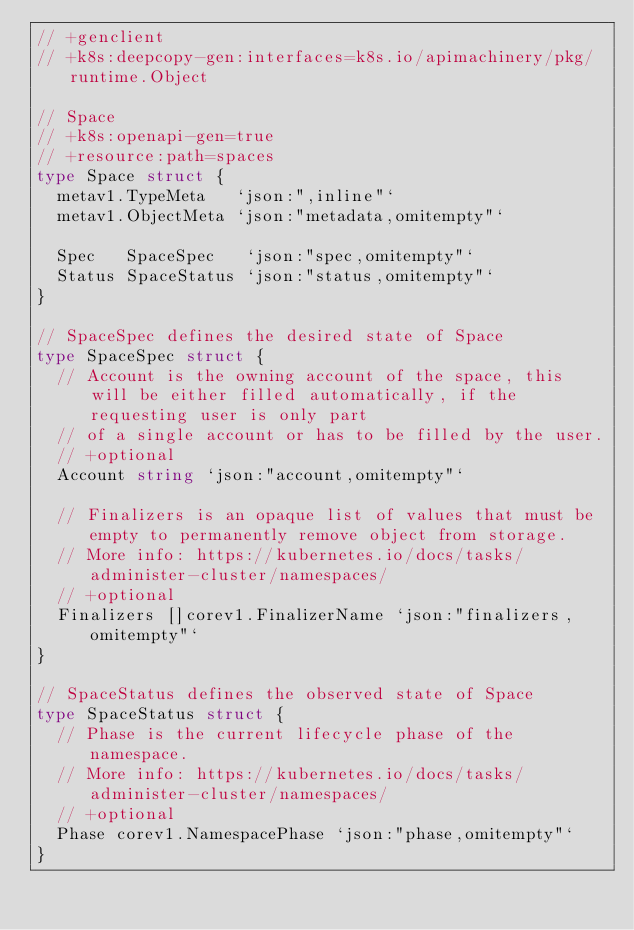<code> <loc_0><loc_0><loc_500><loc_500><_Go_>// +genclient
// +k8s:deepcopy-gen:interfaces=k8s.io/apimachinery/pkg/runtime.Object

// Space
// +k8s:openapi-gen=true
// +resource:path=spaces
type Space struct {
	metav1.TypeMeta   `json:",inline"`
	metav1.ObjectMeta `json:"metadata,omitempty"`

	Spec   SpaceSpec   `json:"spec,omitempty"`
	Status SpaceStatus `json:"status,omitempty"`
}

// SpaceSpec defines the desired state of Space
type SpaceSpec struct {
	// Account is the owning account of the space, this will be either filled automatically, if the requesting user is only part
	// of a single account or has to be filled by the user.
	// +optional
	Account string `json:"account,omitempty"`

	// Finalizers is an opaque list of values that must be empty to permanently remove object from storage.
	// More info: https://kubernetes.io/docs/tasks/administer-cluster/namespaces/
	// +optional
	Finalizers []corev1.FinalizerName `json:"finalizers,omitempty"`
}

// SpaceStatus defines the observed state of Space
type SpaceStatus struct {
	// Phase is the current lifecycle phase of the namespace.
	// More info: https://kubernetes.io/docs/tasks/administer-cluster/namespaces/
	// +optional
	Phase corev1.NamespacePhase `json:"phase,omitempty"`
}
</code> 